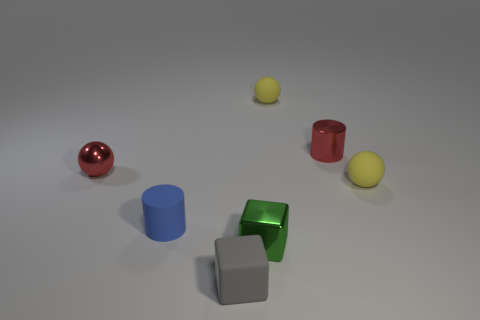What is the color of the tiny object in front of the tiny green metallic object?
Offer a terse response. Gray. How many other things are there of the same size as the metallic cylinder?
Offer a terse response. 6. What size is the object that is both on the left side of the green shiny thing and behind the blue cylinder?
Give a very brief answer. Small. There is a metallic ball; is it the same color as the matte sphere in front of the metal cylinder?
Your answer should be very brief. No. Is there a big blue matte thing that has the same shape as the small blue matte thing?
Your answer should be very brief. No. How many objects are green metal objects or objects that are in front of the red metallic sphere?
Your response must be concise. 4. What number of other things are there of the same material as the blue object
Offer a very short reply. 3. How many objects are either tiny red things or tiny red cylinders?
Ensure brevity in your answer.  2. Is the number of balls that are left of the red sphere greater than the number of red metal objects on the right side of the green metal cube?
Give a very brief answer. No. There is a cube that is behind the rubber cube; is it the same color as the cylinder that is in front of the tiny metallic cylinder?
Offer a terse response. No. 